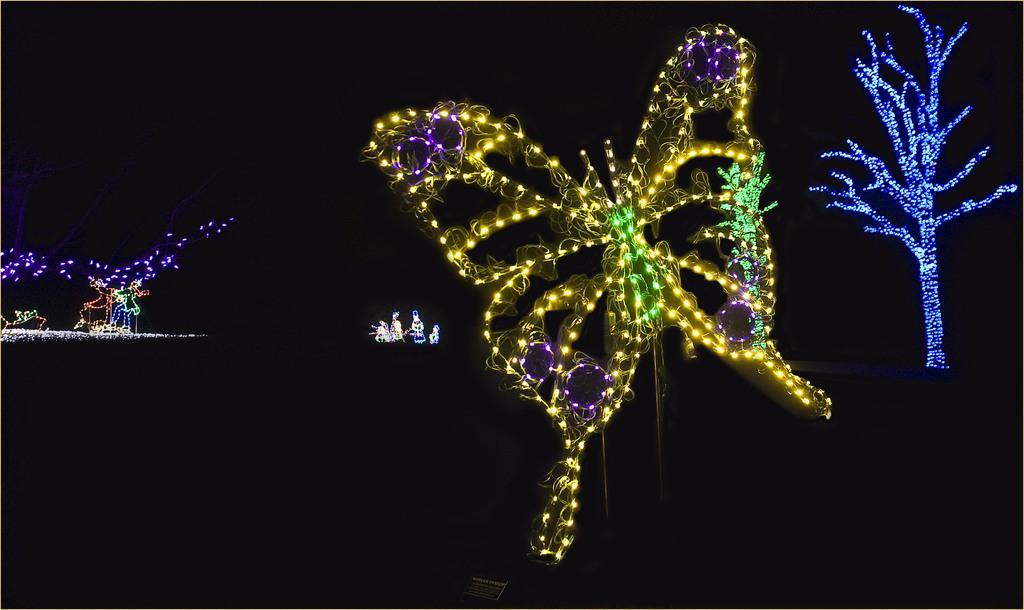How would you summarize this image in a sentence or two? In this image few lights are arranged in the structure of a butterfly. Left side there are few lights. Right side few lights are attached the tree. Background is in black color. 